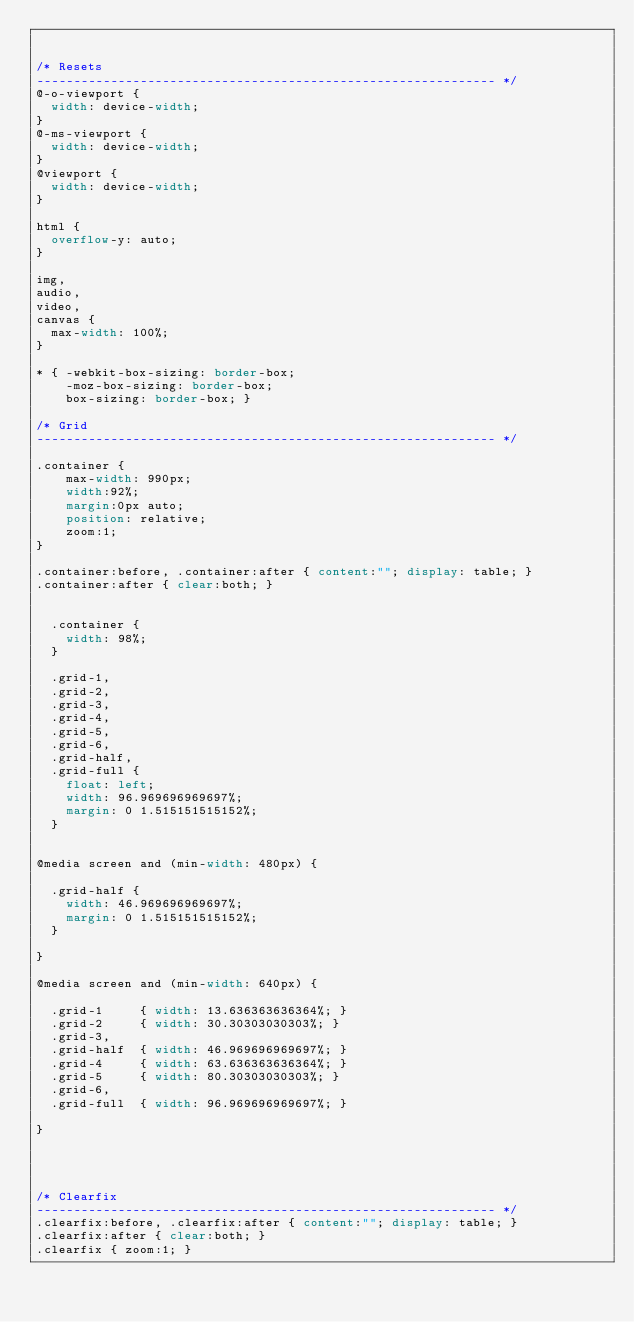Convert code to text. <code><loc_0><loc_0><loc_500><loc_500><_CSS_>

/* Resets
-------------------------------------------------------------- */
@-o-viewport {
  width: device-width;
}
@-ms-viewport {
  width: device-width;
}
@viewport {
  width: device-width;
}

html {
  overflow-y: auto;
}

img,
audio,
video,
canvas {
  max-width: 100%;
}

* { -webkit-box-sizing: border-box;
	-moz-box-sizing: border-box;
	box-sizing: border-box; }

/* Grid
-------------------------------------------------------------- */

.container {
	max-width: 990px;
	width:92%;
	margin:0px auto;
	position: relative;
	zoom:1;
}

.container:before, .container:after { content:""; display: table; }
.container:after { clear:both; }


  .container {
    width: 98%;
  }

  .grid-1,
  .grid-2,
  .grid-3,
  .grid-4,
  .grid-5,
  .grid-6,
  .grid-half,
  .grid-full {
    float: left;
    width: 96.969696969697%;
    margin: 0 1.515151515152%;
  }


@media screen and (min-width: 480px) {

  .grid-half {
    width: 46.969696969697%;
    margin: 0 1.515151515152%;
  }

}

@media screen and (min-width: 640px) {

  .grid-1     { width: 13.636363636364%; }
  .grid-2     { width: 30.30303030303%; }
  .grid-3,
  .grid-half  { width: 46.969696969697%; }
  .grid-4     { width: 63.636363636364%; }
  .grid-5     { width: 80.30303030303%; }
  .grid-6,
  .grid-full  { width: 96.969696969697%; }

}




/* Clearfix
-------------------------------------------------------------- */
.clearfix:before, .clearfix:after { content:""; display: table; }
.clearfix:after { clear:both; }
.clearfix { zoom:1; }</code> 